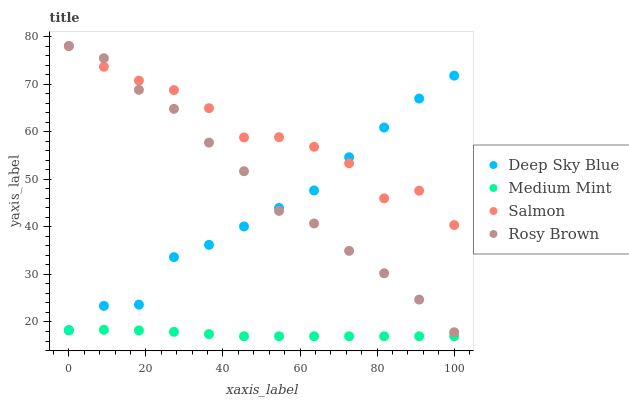Does Medium Mint have the minimum area under the curve?
Answer yes or no. Yes. Does Salmon have the maximum area under the curve?
Answer yes or no. Yes. Does Rosy Brown have the minimum area under the curve?
Answer yes or no. No. Does Rosy Brown have the maximum area under the curve?
Answer yes or no. No. Is Medium Mint the smoothest?
Answer yes or no. Yes. Is Salmon the roughest?
Answer yes or no. Yes. Is Rosy Brown the smoothest?
Answer yes or no. No. Is Rosy Brown the roughest?
Answer yes or no. No. Does Medium Mint have the lowest value?
Answer yes or no. Yes. Does Rosy Brown have the lowest value?
Answer yes or no. No. Does Salmon have the highest value?
Answer yes or no. Yes. Does Deep Sky Blue have the highest value?
Answer yes or no. No. Is Medium Mint less than Rosy Brown?
Answer yes or no. Yes. Is Rosy Brown greater than Medium Mint?
Answer yes or no. Yes. Does Deep Sky Blue intersect Medium Mint?
Answer yes or no. Yes. Is Deep Sky Blue less than Medium Mint?
Answer yes or no. No. Is Deep Sky Blue greater than Medium Mint?
Answer yes or no. No. Does Medium Mint intersect Rosy Brown?
Answer yes or no. No. 